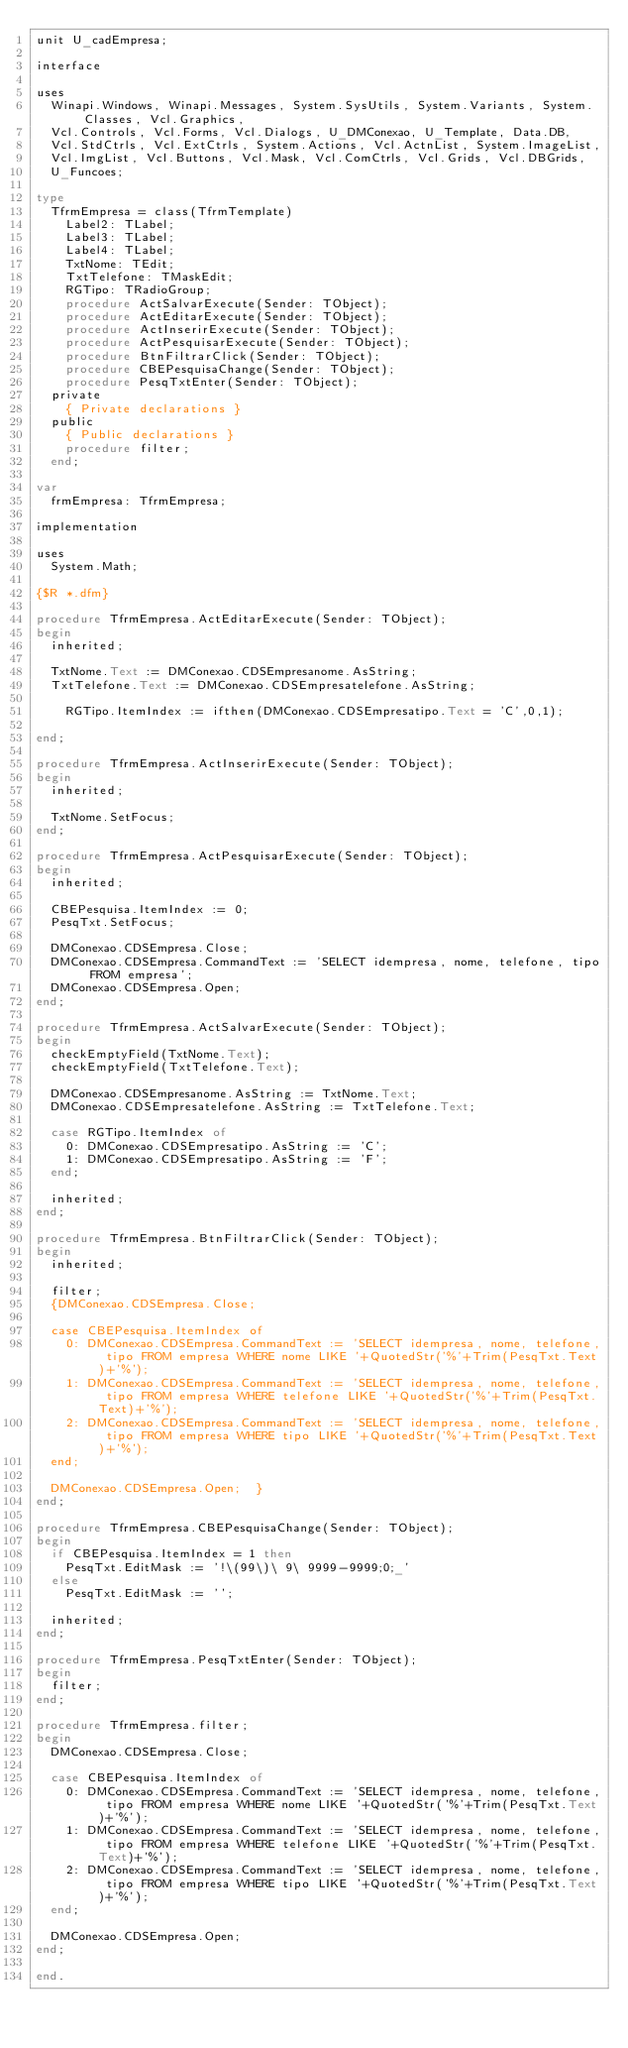Convert code to text. <code><loc_0><loc_0><loc_500><loc_500><_Pascal_>unit U_cadEmpresa;

interface

uses
  Winapi.Windows, Winapi.Messages, System.SysUtils, System.Variants, System.Classes, Vcl.Graphics,
  Vcl.Controls, Vcl.Forms, Vcl.Dialogs, U_DMConexao, U_Template, Data.DB,
  Vcl.StdCtrls, Vcl.ExtCtrls, System.Actions, Vcl.ActnList, System.ImageList,
  Vcl.ImgList, Vcl.Buttons, Vcl.Mask, Vcl.ComCtrls, Vcl.Grids, Vcl.DBGrids,
  U_Funcoes;

type
  TfrmEmpresa = class(TfrmTemplate)
    Label2: TLabel;
    Label3: TLabel;
    Label4: TLabel;
    TxtNome: TEdit;
    TxtTelefone: TMaskEdit;
    RGTipo: TRadioGroup;
    procedure ActSalvarExecute(Sender: TObject);
    procedure ActEditarExecute(Sender: TObject);
    procedure ActInserirExecute(Sender: TObject);
    procedure ActPesquisarExecute(Sender: TObject);
    procedure BtnFiltrarClick(Sender: TObject);
    procedure CBEPesquisaChange(Sender: TObject);
    procedure PesqTxtEnter(Sender: TObject);
  private
    { Private declarations }
  public
    { Public declarations }
    procedure filter;
  end;

var
  frmEmpresa: TfrmEmpresa;

implementation

uses
  System.Math;

{$R *.dfm}

procedure TfrmEmpresa.ActEditarExecute(Sender: TObject);
begin
  inherited;

  TxtNome.Text := DMConexao.CDSEmpresanome.AsString;
  TxtTelefone.Text := DMConexao.CDSEmpresatelefone.AsString;

    RGTipo.ItemIndex := ifthen(DMConexao.CDSEmpresatipo.Text = 'C',0,1);

end;

procedure TfrmEmpresa.ActInserirExecute(Sender: TObject);
begin
  inherited;

  TxtNome.SetFocus;
end;

procedure TfrmEmpresa.ActPesquisarExecute(Sender: TObject);
begin
  inherited;

  CBEPesquisa.ItemIndex := 0;
  PesqTxt.SetFocus;

  DMConexao.CDSEmpresa.Close;
  DMConexao.CDSEmpresa.CommandText := 'SELECT idempresa, nome, telefone, tipo FROM empresa';
  DMConexao.CDSEmpresa.Open;
end;

procedure TfrmEmpresa.ActSalvarExecute(Sender: TObject);
begin
  checkEmptyField(TxtNome.Text);
  checkEmptyField(TxtTelefone.Text);

  DMConexao.CDSEmpresanome.AsString := TxtNome.Text;
  DMConexao.CDSEmpresatelefone.AsString := TxtTelefone.Text;

  case RGTipo.ItemIndex of
    0: DMConexao.CDSEmpresatipo.AsString := 'C';
    1: DMConexao.CDSEmpresatipo.AsString := 'F';
  end;

  inherited;
end;

procedure TfrmEmpresa.BtnFiltrarClick(Sender: TObject);
begin
  inherited;

  filter;
  {DMConexao.CDSEmpresa.Close;

  case CBEPesquisa.ItemIndex of
    0: DMConexao.CDSEmpresa.CommandText := 'SELECT idempresa, nome, telefone, tipo FROM empresa WHERE nome LIKE '+QuotedStr('%'+Trim(PesqTxt.Text)+'%');
    1: DMConexao.CDSEmpresa.CommandText := 'SELECT idempresa, nome, telefone, tipo FROM empresa WHERE telefone LIKE '+QuotedStr('%'+Trim(PesqTxt.Text)+'%');
    2: DMConexao.CDSEmpresa.CommandText := 'SELECT idempresa, nome, telefone, tipo FROM empresa WHERE tipo LIKE '+QuotedStr('%'+Trim(PesqTxt.Text)+'%');
  end;

  DMConexao.CDSEmpresa.Open;  }
end;

procedure TfrmEmpresa.CBEPesquisaChange(Sender: TObject);
begin
  if CBEPesquisa.ItemIndex = 1 then
    PesqTxt.EditMask := '!\(99\)\ 9\ 9999-9999;0;_'
  else
    PesqTxt.EditMask := '';

  inherited;
end;

procedure TfrmEmpresa.PesqTxtEnter(Sender: TObject);
begin
  filter;
end;

procedure TfrmEmpresa.filter;
begin
  DMConexao.CDSEmpresa.Close;

  case CBEPesquisa.ItemIndex of
    0: DMConexao.CDSEmpresa.CommandText := 'SELECT idempresa, nome, telefone, tipo FROM empresa WHERE nome LIKE '+QuotedStr('%'+Trim(PesqTxt.Text)+'%');
    1: DMConexao.CDSEmpresa.CommandText := 'SELECT idempresa, nome, telefone, tipo FROM empresa WHERE telefone LIKE '+QuotedStr('%'+Trim(PesqTxt.Text)+'%');
    2: DMConexao.CDSEmpresa.CommandText := 'SELECT idempresa, nome, telefone, tipo FROM empresa WHERE tipo LIKE '+QuotedStr('%'+Trim(PesqTxt.Text)+'%');
  end;

  DMConexao.CDSEmpresa.Open;
end;

end.
</code> 